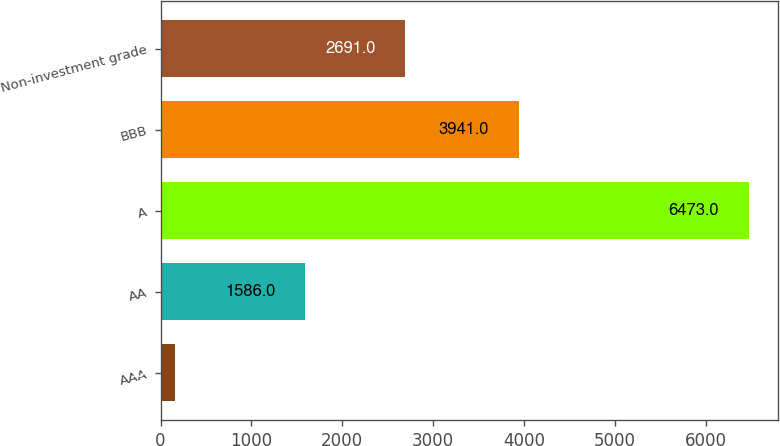Convert chart to OTSL. <chart><loc_0><loc_0><loc_500><loc_500><bar_chart><fcel>AAA<fcel>AA<fcel>A<fcel>BBB<fcel>Non-investment grade<nl><fcel>157<fcel>1586<fcel>6473<fcel>3941<fcel>2691<nl></chart> 